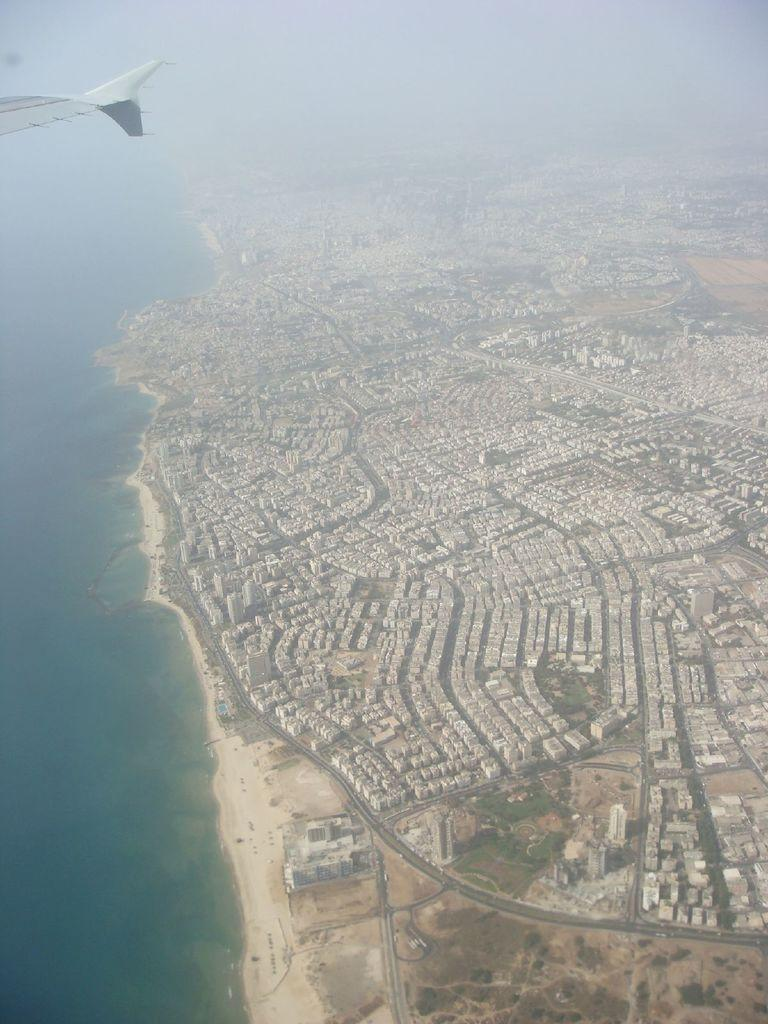What can be seen on the left side of the image? There is water on the left side of the image. What is located on the right side of the image? There are buildings, a walkway, trees, and sand on the right side of the image. Can you describe the walkway in the image? The walkway is on the right side of the image. What is visible in the top left hand corner of the image? There is an airplane in the top left hand corner of the image. What type of linen can be seen draped over the trees in the image? There is no linen draped over the trees in the image; the trees are not covered by any fabric. How many flowers are visible in the image? There are no flowers present in the image. 